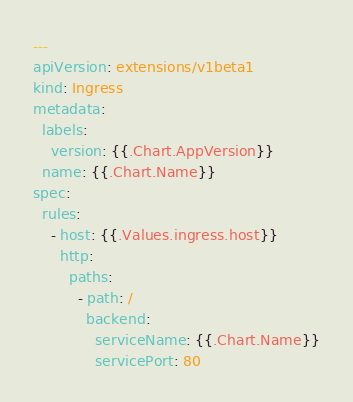Convert code to text. <code><loc_0><loc_0><loc_500><loc_500><_YAML_>---
apiVersion: extensions/v1beta1
kind: Ingress
metadata:
  labels:
    version: {{.Chart.AppVersion}}
  name: {{.Chart.Name}}
spec:
  rules:
    - host: {{.Values.ingress.host}}
      http:
        paths:
          - path: /
            backend:
              serviceName: {{.Chart.Name}}
              servicePort: 80</code> 